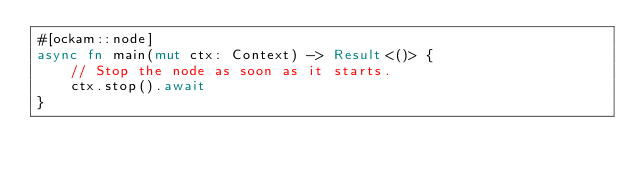<code> <loc_0><loc_0><loc_500><loc_500><_Rust_>#[ockam::node]
async fn main(mut ctx: Context) -> Result<()> {
    // Stop the node as soon as it starts.
    ctx.stop().await
}
</code> 